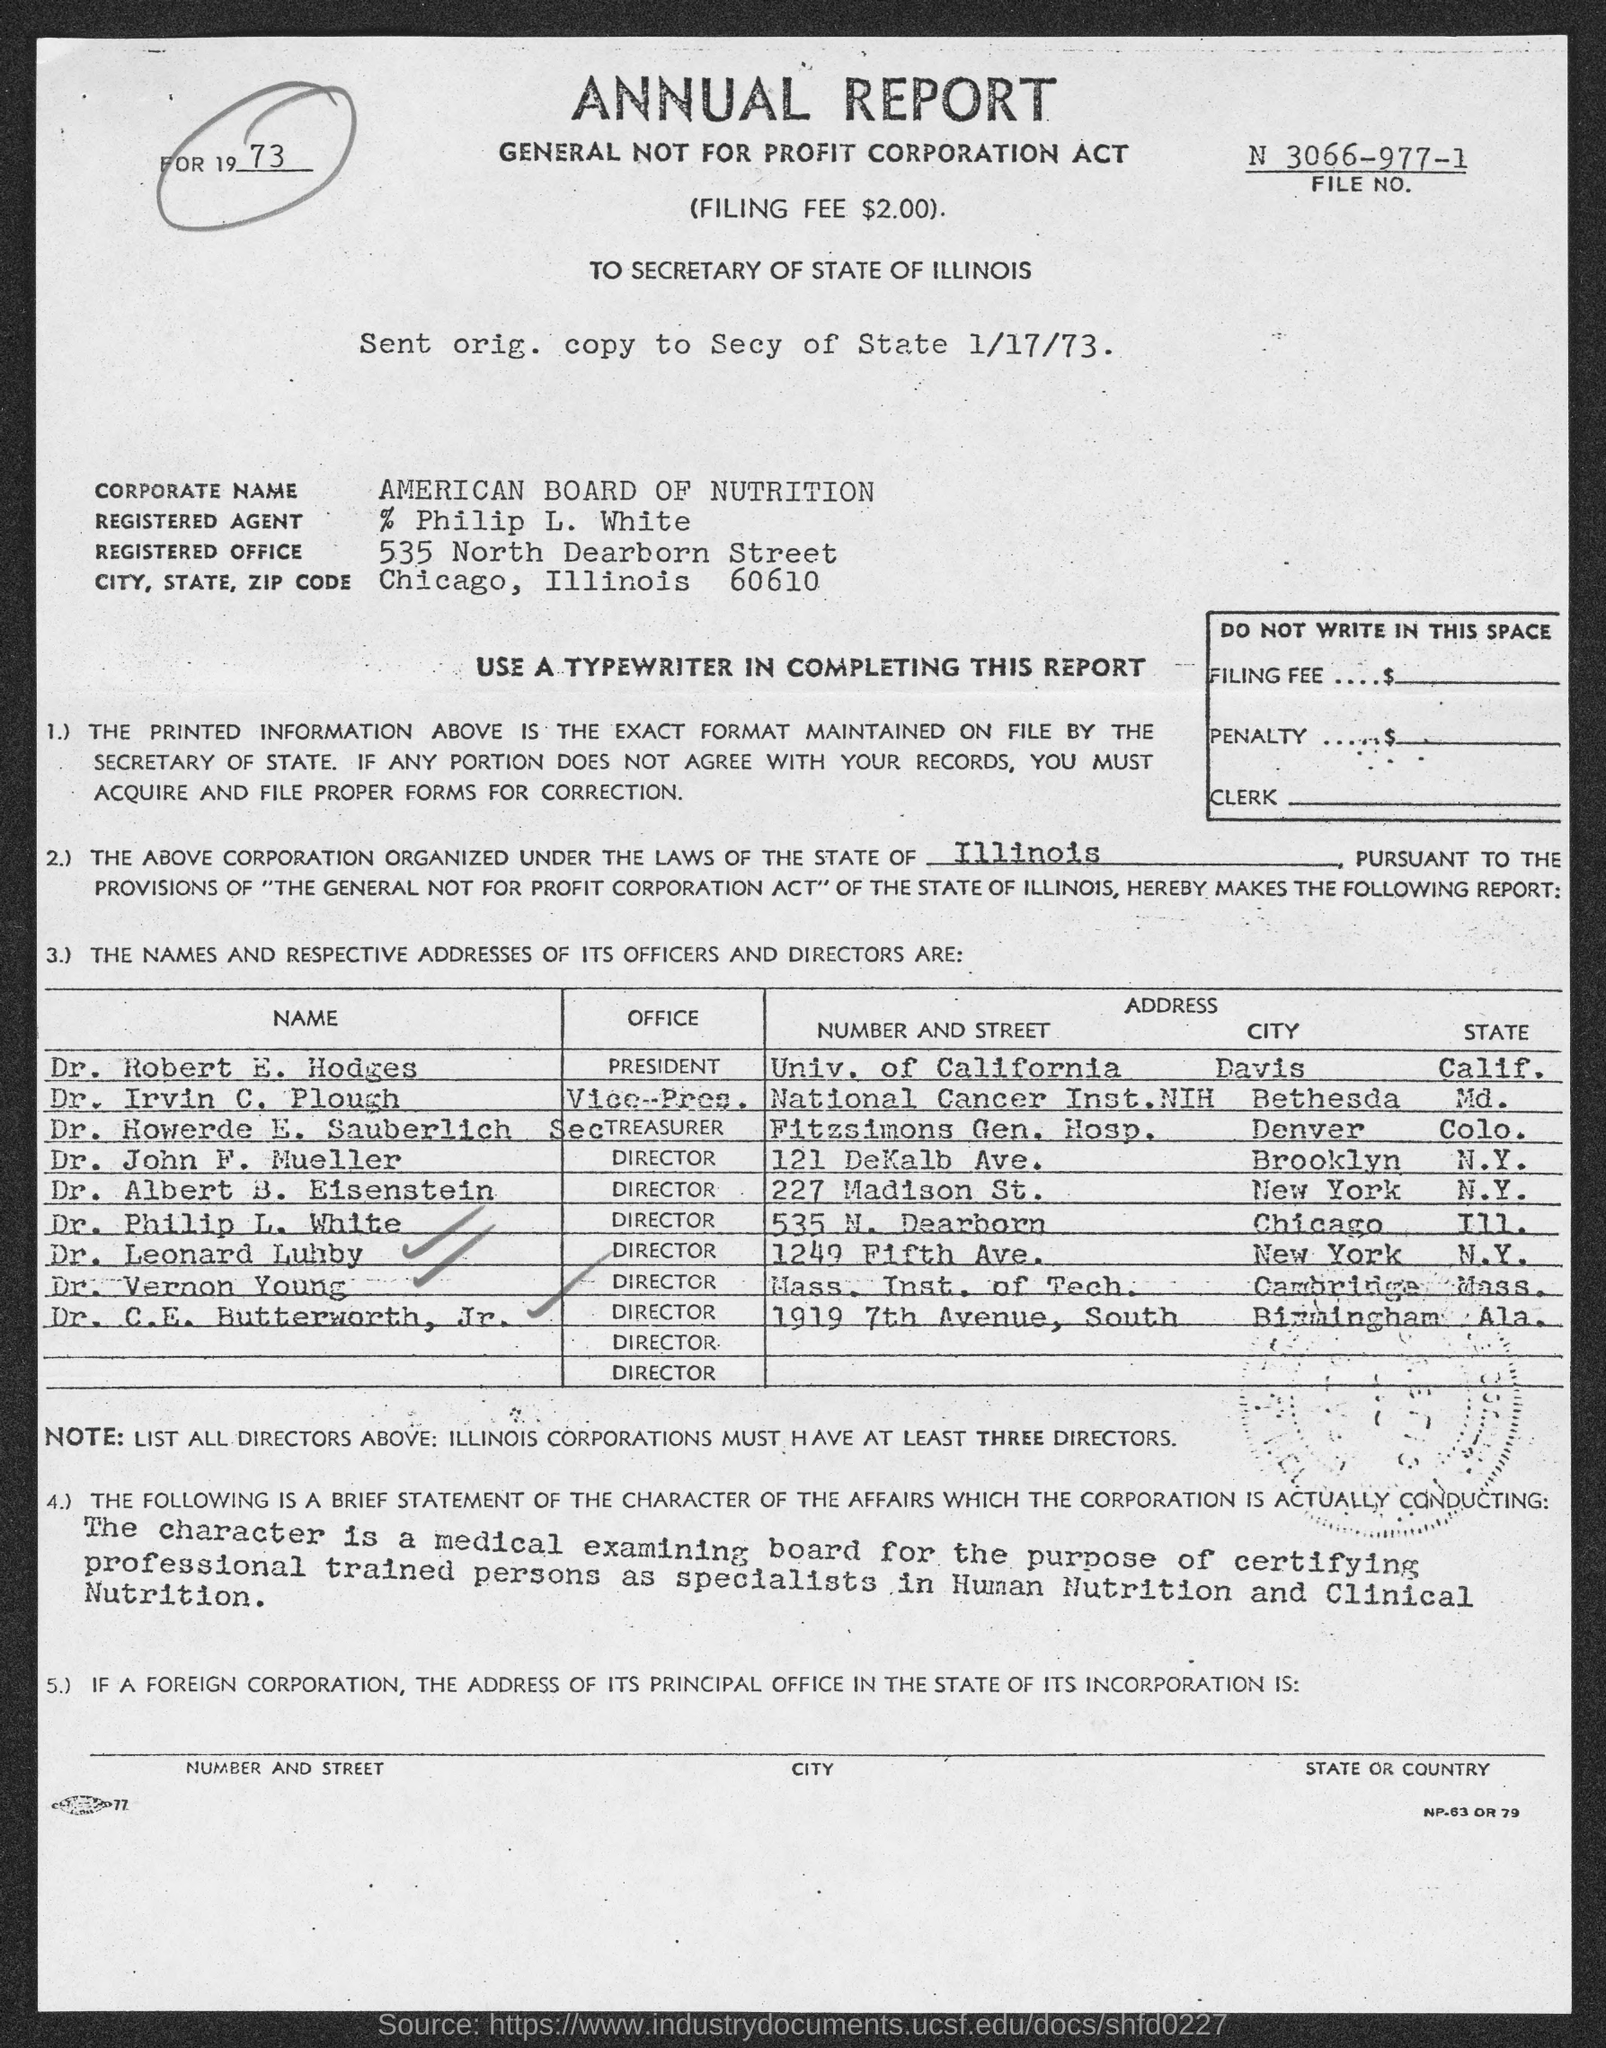Indicate a few pertinent items in this graphic. The registered office address is located at 535 North Dearborn Street. The corporate name is the American Board of Nutrition. Dr. Robert E. Hodges is the president of his office. Dr. Albert B. Eisenstein is the director of a specific office. The office of Dr. John F. Mueller is that of a director. 